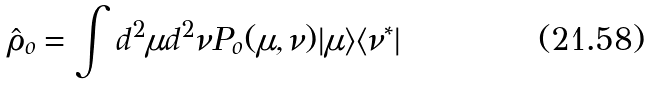Convert formula to latex. <formula><loc_0><loc_0><loc_500><loc_500>\hat { \rho } _ { o } = \int d ^ { 2 } \mu d ^ { 2 } \nu P _ { o } ( \mu , \nu ) | \mu \rangle \langle \nu ^ { * } |</formula> 